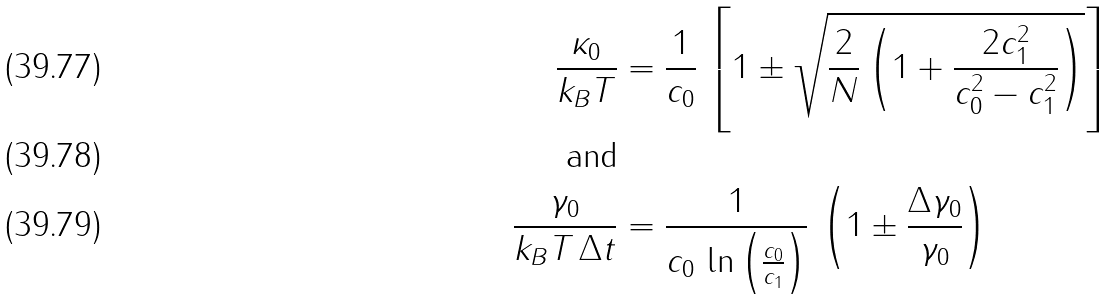Convert formula to latex. <formula><loc_0><loc_0><loc_500><loc_500>\frac { \kappa _ { 0 } } { k _ { B } T } & = \frac { 1 } { c _ { 0 } } \, \left [ 1 \pm \sqrt { \frac { 2 } { N } \left ( 1 + \frac { 2 c _ { 1 } ^ { 2 } } { c _ { 0 } ^ { 2 } - c _ { 1 } ^ { 2 } } \right ) } \right ] \\ \text {and} \\ \frac { \gamma _ { 0 } } { k _ { B } T \, \Delta t } & = \frac { 1 } { c _ { 0 } \, \ln \left ( \frac { c _ { 0 } } { c _ { 1 } } \right ) } \, \left ( 1 \pm \frac { \Delta \gamma _ { 0 } } { \gamma _ { 0 } } \right )</formula> 